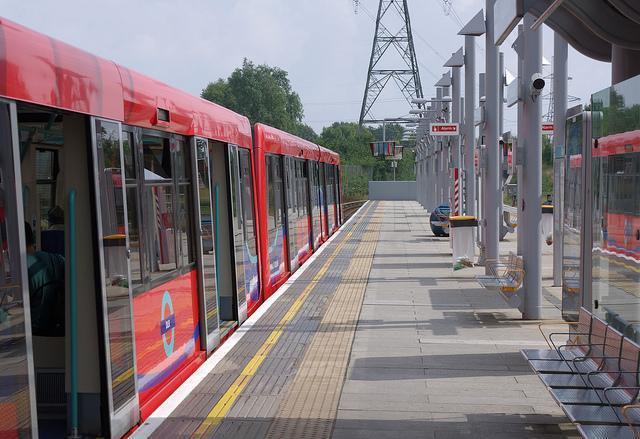How many trains are there?
Give a very brief answer. 2. How many chairs are visible?
Give a very brief answer. 2. How many sinks are next to the toilet?
Give a very brief answer. 0. 